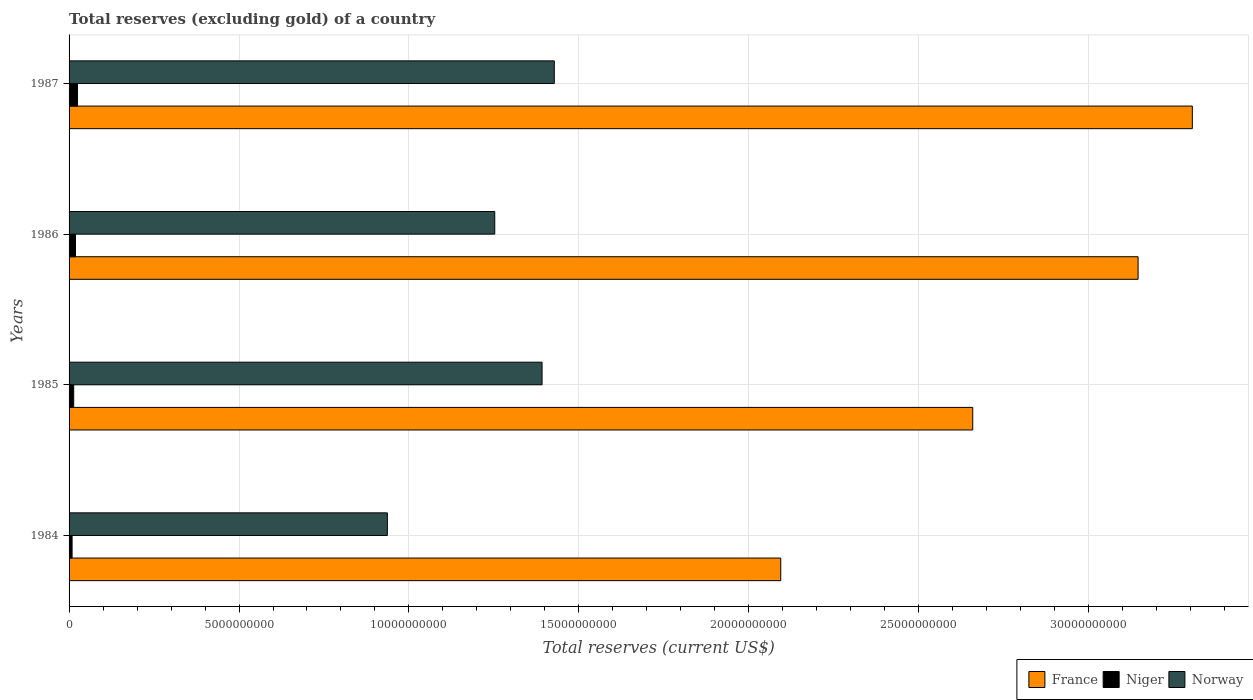How many different coloured bars are there?
Make the answer very short. 3. Are the number of bars per tick equal to the number of legend labels?
Your response must be concise. Yes. Are the number of bars on each tick of the Y-axis equal?
Make the answer very short. Yes. How many bars are there on the 1st tick from the top?
Your answer should be compact. 3. What is the total reserves (excluding gold) in Niger in 1985?
Offer a very short reply. 1.36e+08. Across all years, what is the maximum total reserves (excluding gold) in Niger?
Give a very brief answer. 2.48e+08. Across all years, what is the minimum total reserves (excluding gold) in Niger?
Provide a succinct answer. 8.87e+07. In which year was the total reserves (excluding gold) in France minimum?
Provide a succinct answer. 1984. What is the total total reserves (excluding gold) in Niger in the graph?
Your answer should be compact. 6.63e+08. What is the difference between the total reserves (excluding gold) in Niger in 1985 and that in 1986?
Provide a short and direct response. -5.28e+07. What is the difference between the total reserves (excluding gold) in Niger in 1985 and the total reserves (excluding gold) in France in 1986?
Your answer should be very brief. -3.13e+1. What is the average total reserves (excluding gold) in Niger per year?
Offer a terse response. 1.66e+08. In the year 1985, what is the difference between the total reserves (excluding gold) in France and total reserves (excluding gold) in Niger?
Offer a terse response. 2.65e+1. What is the ratio of the total reserves (excluding gold) in Niger in 1984 to that in 1986?
Give a very brief answer. 0.47. Is the difference between the total reserves (excluding gold) in France in 1984 and 1986 greater than the difference between the total reserves (excluding gold) in Niger in 1984 and 1986?
Make the answer very short. No. What is the difference between the highest and the second highest total reserves (excluding gold) in Norway?
Provide a succinct answer. 3.60e+08. What is the difference between the highest and the lowest total reserves (excluding gold) in Norway?
Your response must be concise. 4.91e+09. What does the 2nd bar from the bottom in 1985 represents?
Offer a terse response. Niger. Is it the case that in every year, the sum of the total reserves (excluding gold) in Norway and total reserves (excluding gold) in Niger is greater than the total reserves (excluding gold) in France?
Give a very brief answer. No. Are the values on the major ticks of X-axis written in scientific E-notation?
Your answer should be very brief. No. Does the graph contain any zero values?
Keep it short and to the point. No. Does the graph contain grids?
Give a very brief answer. Yes. Where does the legend appear in the graph?
Your response must be concise. Bottom right. How are the legend labels stacked?
Your answer should be very brief. Horizontal. What is the title of the graph?
Provide a short and direct response. Total reserves (excluding gold) of a country. Does "Nepal" appear as one of the legend labels in the graph?
Offer a terse response. No. What is the label or title of the X-axis?
Your answer should be compact. Total reserves (current US$). What is the Total reserves (current US$) of France in 1984?
Ensure brevity in your answer.  2.09e+1. What is the Total reserves (current US$) of Niger in 1984?
Your answer should be compact. 8.87e+07. What is the Total reserves (current US$) of Norway in 1984?
Your answer should be compact. 9.37e+09. What is the Total reserves (current US$) of France in 1985?
Give a very brief answer. 2.66e+1. What is the Total reserves (current US$) of Niger in 1985?
Your answer should be very brief. 1.36e+08. What is the Total reserves (current US$) in Norway in 1985?
Keep it short and to the point. 1.39e+1. What is the Total reserves (current US$) of France in 1986?
Keep it short and to the point. 3.15e+1. What is the Total reserves (current US$) of Niger in 1986?
Keep it short and to the point. 1.89e+08. What is the Total reserves (current US$) of Norway in 1986?
Offer a very short reply. 1.25e+1. What is the Total reserves (current US$) of France in 1987?
Keep it short and to the point. 3.30e+1. What is the Total reserves (current US$) of Niger in 1987?
Make the answer very short. 2.48e+08. What is the Total reserves (current US$) of Norway in 1987?
Make the answer very short. 1.43e+1. Across all years, what is the maximum Total reserves (current US$) of France?
Make the answer very short. 3.30e+1. Across all years, what is the maximum Total reserves (current US$) in Niger?
Offer a terse response. 2.48e+08. Across all years, what is the maximum Total reserves (current US$) of Norway?
Provide a succinct answer. 1.43e+1. Across all years, what is the minimum Total reserves (current US$) in France?
Your answer should be very brief. 2.09e+1. Across all years, what is the minimum Total reserves (current US$) of Niger?
Your answer should be very brief. 8.87e+07. Across all years, what is the minimum Total reserves (current US$) in Norway?
Your answer should be very brief. 9.37e+09. What is the total Total reserves (current US$) of France in the graph?
Provide a short and direct response. 1.12e+11. What is the total Total reserves (current US$) in Niger in the graph?
Offer a terse response. 6.63e+08. What is the total Total reserves (current US$) of Norway in the graph?
Offer a very short reply. 5.01e+1. What is the difference between the Total reserves (current US$) in France in 1984 and that in 1985?
Offer a very short reply. -5.65e+09. What is the difference between the Total reserves (current US$) in Niger in 1984 and that in 1985?
Your answer should be very brief. -4.77e+07. What is the difference between the Total reserves (current US$) of Norway in 1984 and that in 1985?
Ensure brevity in your answer.  -4.55e+09. What is the difference between the Total reserves (current US$) of France in 1984 and that in 1986?
Your response must be concise. -1.05e+1. What is the difference between the Total reserves (current US$) of Niger in 1984 and that in 1986?
Ensure brevity in your answer.  -1.01e+08. What is the difference between the Total reserves (current US$) in Norway in 1984 and that in 1986?
Provide a succinct answer. -3.16e+09. What is the difference between the Total reserves (current US$) in France in 1984 and that in 1987?
Offer a terse response. -1.21e+1. What is the difference between the Total reserves (current US$) of Niger in 1984 and that in 1987?
Make the answer very short. -1.60e+08. What is the difference between the Total reserves (current US$) in Norway in 1984 and that in 1987?
Your answer should be compact. -4.91e+09. What is the difference between the Total reserves (current US$) of France in 1985 and that in 1986?
Your response must be concise. -4.87e+09. What is the difference between the Total reserves (current US$) in Niger in 1985 and that in 1986?
Your answer should be compact. -5.28e+07. What is the difference between the Total reserves (current US$) of Norway in 1985 and that in 1986?
Your answer should be compact. 1.39e+09. What is the difference between the Total reserves (current US$) in France in 1985 and that in 1987?
Your answer should be very brief. -6.46e+09. What is the difference between the Total reserves (current US$) of Niger in 1985 and that in 1987?
Your response must be concise. -1.12e+08. What is the difference between the Total reserves (current US$) in Norway in 1985 and that in 1987?
Offer a very short reply. -3.60e+08. What is the difference between the Total reserves (current US$) of France in 1986 and that in 1987?
Offer a terse response. -1.60e+09. What is the difference between the Total reserves (current US$) of Niger in 1986 and that in 1987?
Your answer should be very brief. -5.92e+07. What is the difference between the Total reserves (current US$) in Norway in 1986 and that in 1987?
Keep it short and to the point. -1.75e+09. What is the difference between the Total reserves (current US$) in France in 1984 and the Total reserves (current US$) in Niger in 1985?
Your response must be concise. 2.08e+1. What is the difference between the Total reserves (current US$) of France in 1984 and the Total reserves (current US$) of Norway in 1985?
Your answer should be very brief. 7.02e+09. What is the difference between the Total reserves (current US$) of Niger in 1984 and the Total reserves (current US$) of Norway in 1985?
Give a very brief answer. -1.38e+1. What is the difference between the Total reserves (current US$) of France in 1984 and the Total reserves (current US$) of Niger in 1986?
Provide a short and direct response. 2.08e+1. What is the difference between the Total reserves (current US$) in France in 1984 and the Total reserves (current US$) in Norway in 1986?
Provide a short and direct response. 8.41e+09. What is the difference between the Total reserves (current US$) of Niger in 1984 and the Total reserves (current US$) of Norway in 1986?
Your response must be concise. -1.24e+1. What is the difference between the Total reserves (current US$) in France in 1984 and the Total reserves (current US$) in Niger in 1987?
Make the answer very short. 2.07e+1. What is the difference between the Total reserves (current US$) of France in 1984 and the Total reserves (current US$) of Norway in 1987?
Give a very brief answer. 6.66e+09. What is the difference between the Total reserves (current US$) in Niger in 1984 and the Total reserves (current US$) in Norway in 1987?
Provide a succinct answer. -1.42e+1. What is the difference between the Total reserves (current US$) of France in 1985 and the Total reserves (current US$) of Niger in 1986?
Make the answer very short. 2.64e+1. What is the difference between the Total reserves (current US$) in France in 1985 and the Total reserves (current US$) in Norway in 1986?
Make the answer very short. 1.41e+1. What is the difference between the Total reserves (current US$) in Niger in 1985 and the Total reserves (current US$) in Norway in 1986?
Offer a terse response. -1.24e+1. What is the difference between the Total reserves (current US$) in France in 1985 and the Total reserves (current US$) in Niger in 1987?
Your answer should be compact. 2.63e+1. What is the difference between the Total reserves (current US$) of France in 1985 and the Total reserves (current US$) of Norway in 1987?
Provide a succinct answer. 1.23e+1. What is the difference between the Total reserves (current US$) of Niger in 1985 and the Total reserves (current US$) of Norway in 1987?
Offer a very short reply. -1.41e+1. What is the difference between the Total reserves (current US$) of France in 1986 and the Total reserves (current US$) of Niger in 1987?
Your answer should be very brief. 3.12e+1. What is the difference between the Total reserves (current US$) in France in 1986 and the Total reserves (current US$) in Norway in 1987?
Your answer should be compact. 1.72e+1. What is the difference between the Total reserves (current US$) of Niger in 1986 and the Total reserves (current US$) of Norway in 1987?
Your answer should be very brief. -1.41e+1. What is the average Total reserves (current US$) of France per year?
Make the answer very short. 2.80e+1. What is the average Total reserves (current US$) of Niger per year?
Offer a very short reply. 1.66e+08. What is the average Total reserves (current US$) of Norway per year?
Your answer should be very brief. 1.25e+1. In the year 1984, what is the difference between the Total reserves (current US$) in France and Total reserves (current US$) in Niger?
Your answer should be very brief. 2.09e+1. In the year 1984, what is the difference between the Total reserves (current US$) in France and Total reserves (current US$) in Norway?
Keep it short and to the point. 1.16e+1. In the year 1984, what is the difference between the Total reserves (current US$) of Niger and Total reserves (current US$) of Norway?
Offer a terse response. -9.28e+09. In the year 1985, what is the difference between the Total reserves (current US$) of France and Total reserves (current US$) of Niger?
Provide a succinct answer. 2.65e+1. In the year 1985, what is the difference between the Total reserves (current US$) in France and Total reserves (current US$) in Norway?
Your answer should be compact. 1.27e+1. In the year 1985, what is the difference between the Total reserves (current US$) of Niger and Total reserves (current US$) of Norway?
Your answer should be very brief. -1.38e+1. In the year 1986, what is the difference between the Total reserves (current US$) in France and Total reserves (current US$) in Niger?
Your answer should be very brief. 3.13e+1. In the year 1986, what is the difference between the Total reserves (current US$) of France and Total reserves (current US$) of Norway?
Offer a terse response. 1.89e+1. In the year 1986, what is the difference between the Total reserves (current US$) in Niger and Total reserves (current US$) in Norway?
Your response must be concise. -1.23e+1. In the year 1987, what is the difference between the Total reserves (current US$) of France and Total reserves (current US$) of Niger?
Offer a terse response. 3.28e+1. In the year 1987, what is the difference between the Total reserves (current US$) in France and Total reserves (current US$) in Norway?
Provide a short and direct response. 1.88e+1. In the year 1987, what is the difference between the Total reserves (current US$) in Niger and Total reserves (current US$) in Norway?
Your answer should be very brief. -1.40e+1. What is the ratio of the Total reserves (current US$) in France in 1984 to that in 1985?
Offer a very short reply. 0.79. What is the ratio of the Total reserves (current US$) of Niger in 1984 to that in 1985?
Ensure brevity in your answer.  0.65. What is the ratio of the Total reserves (current US$) in Norway in 1984 to that in 1985?
Your answer should be very brief. 0.67. What is the ratio of the Total reserves (current US$) in France in 1984 to that in 1986?
Offer a very short reply. 0.67. What is the ratio of the Total reserves (current US$) of Niger in 1984 to that in 1986?
Make the answer very short. 0.47. What is the ratio of the Total reserves (current US$) of Norway in 1984 to that in 1986?
Your answer should be very brief. 0.75. What is the ratio of the Total reserves (current US$) in France in 1984 to that in 1987?
Your response must be concise. 0.63. What is the ratio of the Total reserves (current US$) of Niger in 1984 to that in 1987?
Your answer should be very brief. 0.36. What is the ratio of the Total reserves (current US$) of Norway in 1984 to that in 1987?
Your answer should be very brief. 0.66. What is the ratio of the Total reserves (current US$) in France in 1985 to that in 1986?
Provide a short and direct response. 0.85. What is the ratio of the Total reserves (current US$) of Niger in 1985 to that in 1986?
Provide a short and direct response. 0.72. What is the ratio of the Total reserves (current US$) in Norway in 1985 to that in 1986?
Keep it short and to the point. 1.11. What is the ratio of the Total reserves (current US$) of France in 1985 to that in 1987?
Make the answer very short. 0.8. What is the ratio of the Total reserves (current US$) of Niger in 1985 to that in 1987?
Give a very brief answer. 0.55. What is the ratio of the Total reserves (current US$) of Norway in 1985 to that in 1987?
Your answer should be compact. 0.97. What is the ratio of the Total reserves (current US$) of France in 1986 to that in 1987?
Offer a terse response. 0.95. What is the ratio of the Total reserves (current US$) of Niger in 1986 to that in 1987?
Make the answer very short. 0.76. What is the ratio of the Total reserves (current US$) in Norway in 1986 to that in 1987?
Give a very brief answer. 0.88. What is the difference between the highest and the second highest Total reserves (current US$) in France?
Your response must be concise. 1.60e+09. What is the difference between the highest and the second highest Total reserves (current US$) of Niger?
Keep it short and to the point. 5.92e+07. What is the difference between the highest and the second highest Total reserves (current US$) of Norway?
Offer a terse response. 3.60e+08. What is the difference between the highest and the lowest Total reserves (current US$) of France?
Your response must be concise. 1.21e+1. What is the difference between the highest and the lowest Total reserves (current US$) of Niger?
Your answer should be compact. 1.60e+08. What is the difference between the highest and the lowest Total reserves (current US$) in Norway?
Give a very brief answer. 4.91e+09. 